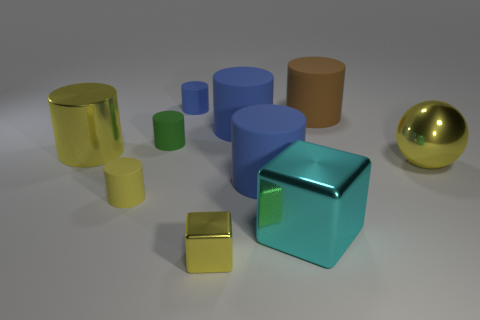What number of small cubes are behind the small yellow object that is behind the small shiny object?
Your response must be concise. 0. There is a thing that is behind the big yellow sphere and on the left side of the tiny green thing; what is its shape?
Your answer should be very brief. Cylinder. What is the blue cylinder that is to the left of the big blue rubber cylinder that is behind the big metallic object that is to the left of the tiny blue matte cylinder made of?
Make the answer very short. Rubber. There is a rubber cylinder that is the same color as the tiny block; what is its size?
Your answer should be compact. Small. What is the large sphere made of?
Give a very brief answer. Metal. Do the tiny green thing and the yellow cylinder that is to the left of the small yellow matte cylinder have the same material?
Ensure brevity in your answer.  No. The matte cylinder that is on the left side of the tiny green matte cylinder behind the large cyan shiny block is what color?
Provide a short and direct response. Yellow. What size is the metallic thing that is left of the yellow ball and behind the big cyan metal object?
Offer a terse response. Large. How many other objects are the same shape as the tiny yellow metal object?
Provide a succinct answer. 1. There is a small blue object; is its shape the same as the yellow object right of the yellow metal block?
Offer a terse response. No. 